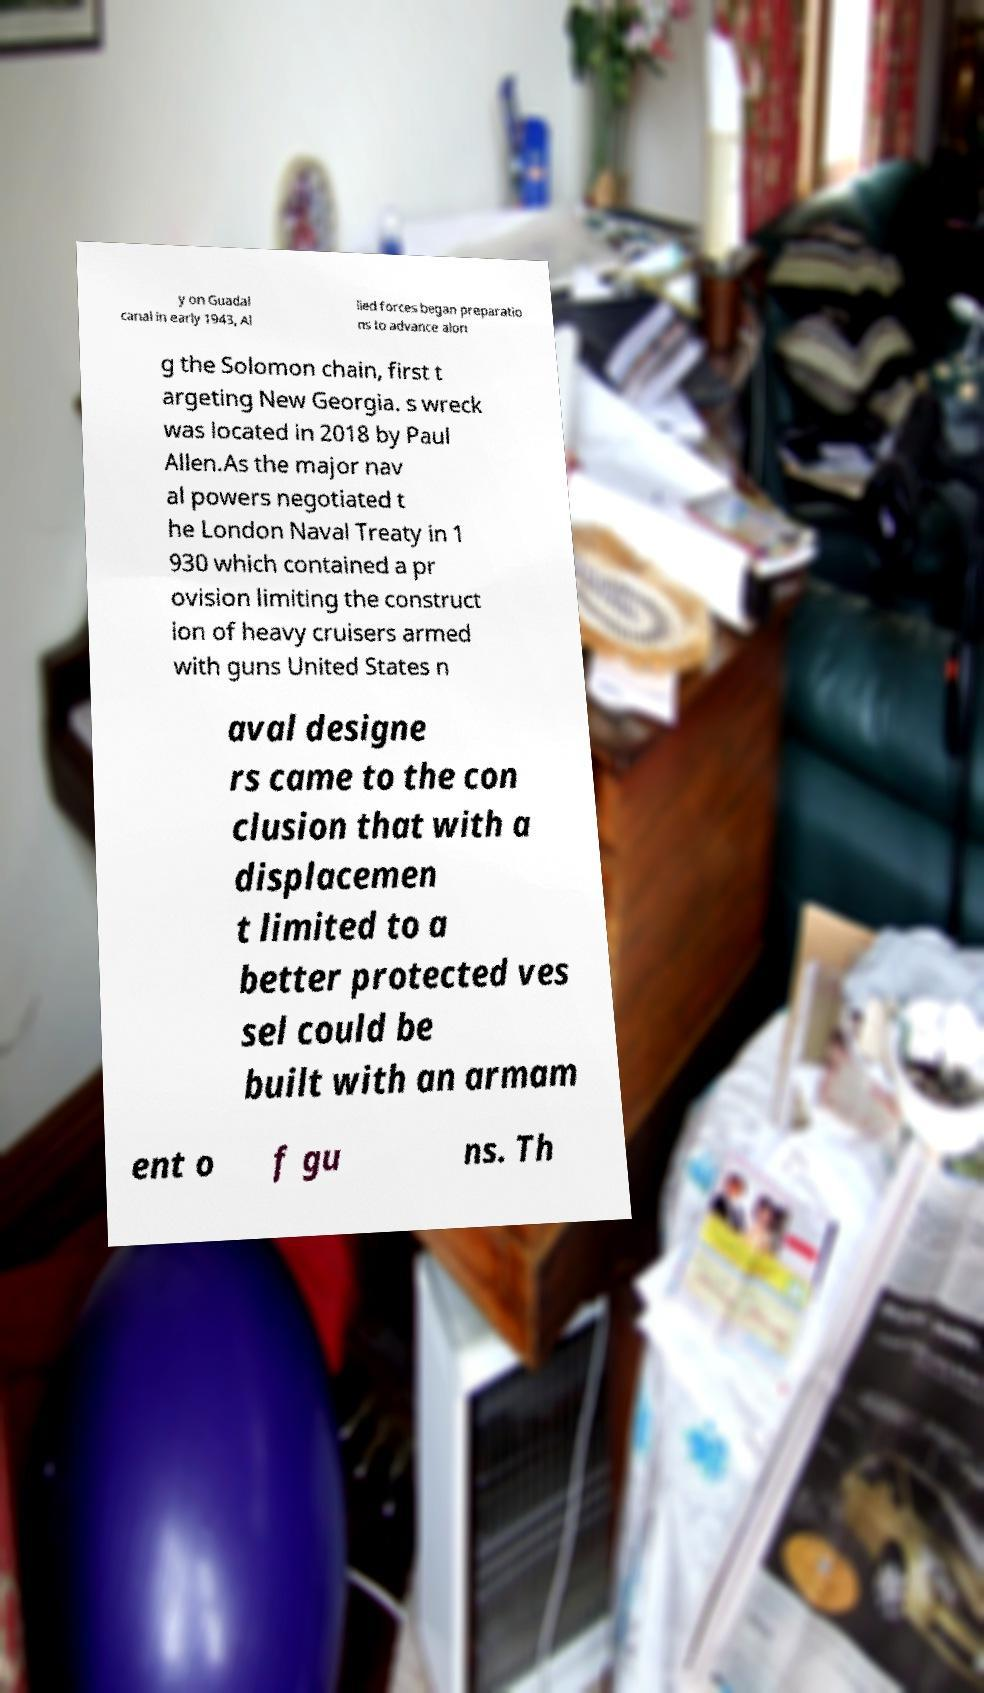What messages or text are displayed in this image? I need them in a readable, typed format. y on Guadal canal in early 1943, Al lied forces began preparatio ns to advance alon g the Solomon chain, first t argeting New Georgia. s wreck was located in 2018 by Paul Allen.As the major nav al powers negotiated t he London Naval Treaty in 1 930 which contained a pr ovision limiting the construct ion of heavy cruisers armed with guns United States n aval designe rs came to the con clusion that with a displacemen t limited to a better protected ves sel could be built with an armam ent o f gu ns. Th 